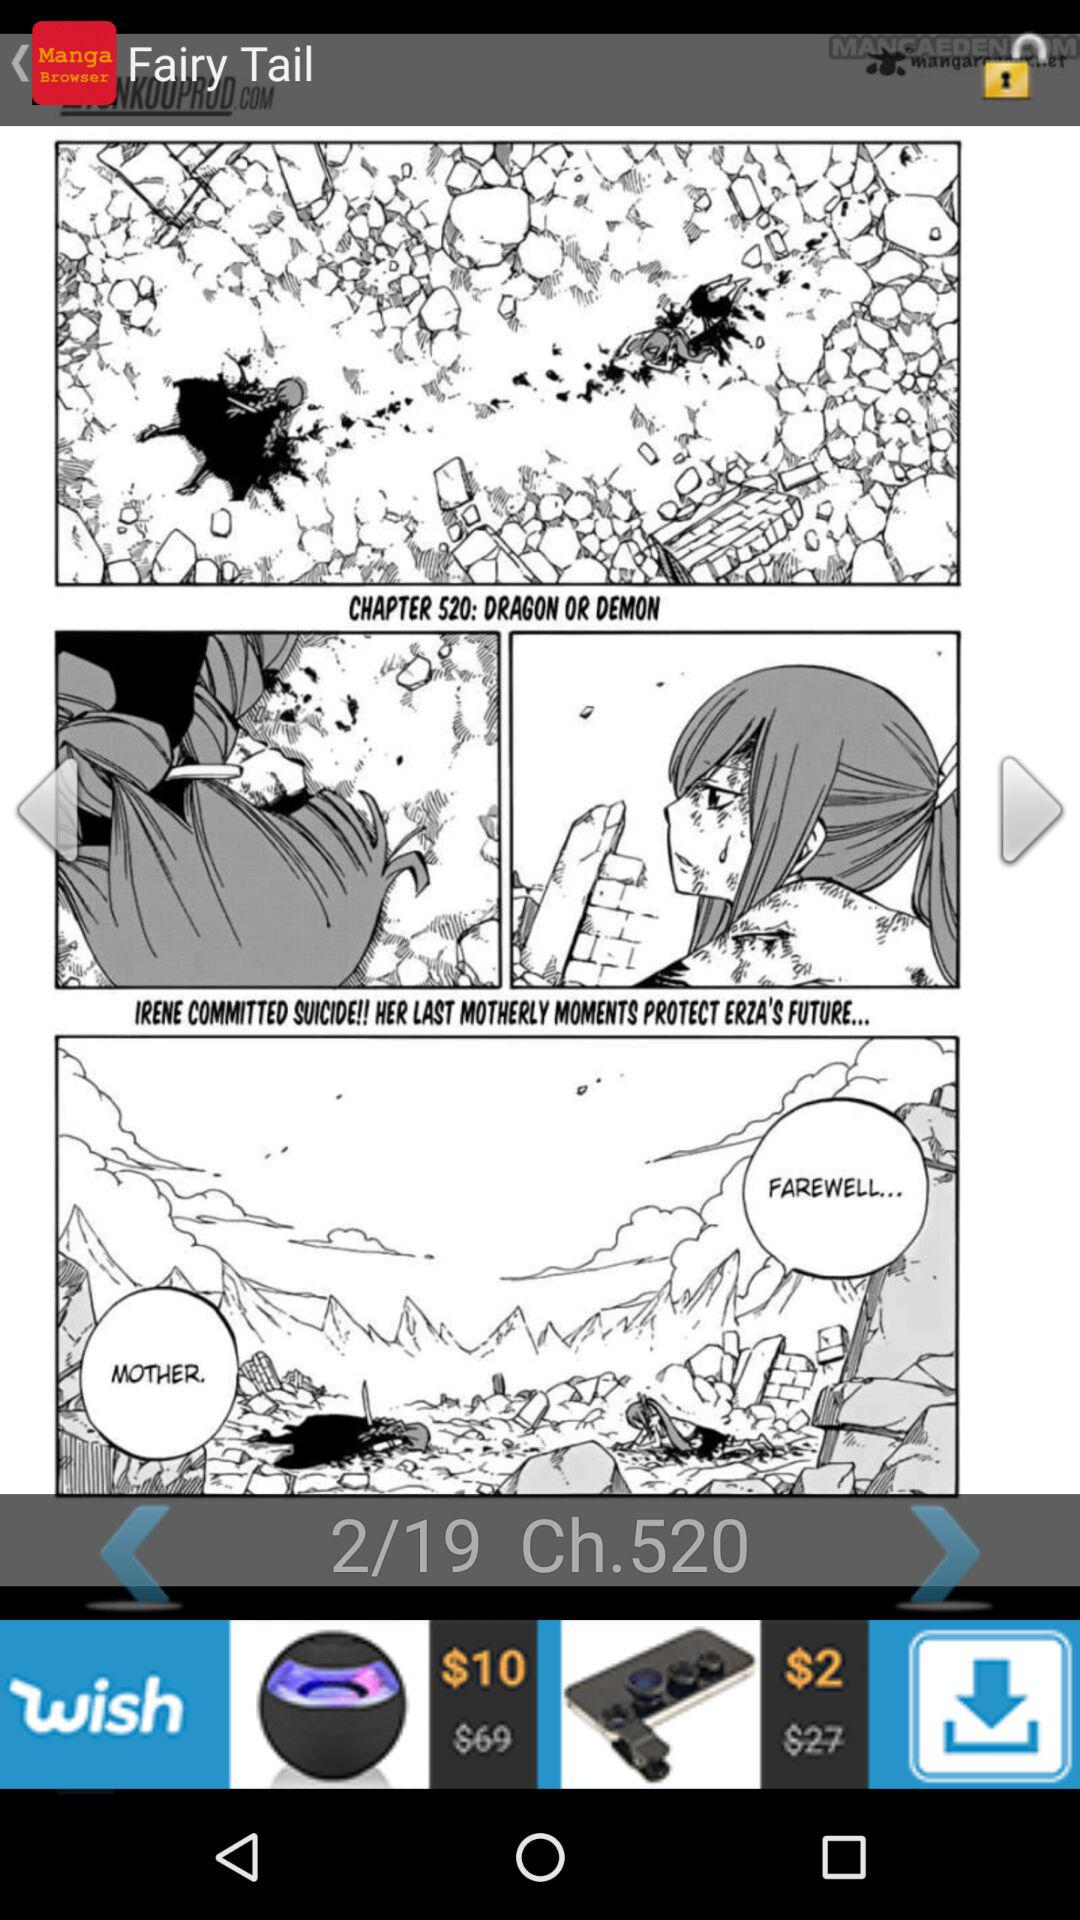What is the number of the chapter? The number of the chapter is 520. 